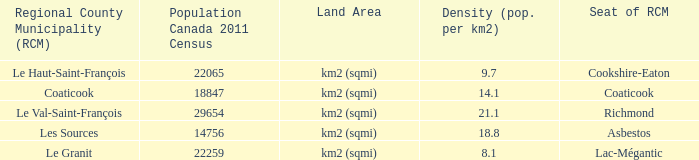What is the RCM that has a density of 9.7? Le Haut-Saint-François. 